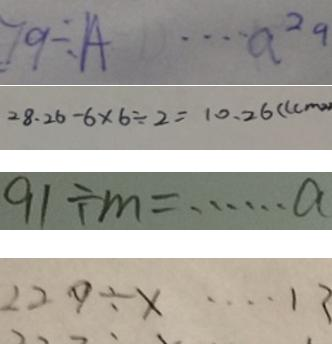Convert formula to latex. <formula><loc_0><loc_0><loc_500><loc_500>7 9 \div A \cdots a ^ { 2 9 } 
 2 8 . 2 6 - 6 \times 6 \div 2 = 1 0 . 2 6 ( ( c m ^ { 2 } ) 
 9 0 \div m = \cdots a 
 2 2 9 \div x \cdots 1 3</formula> 